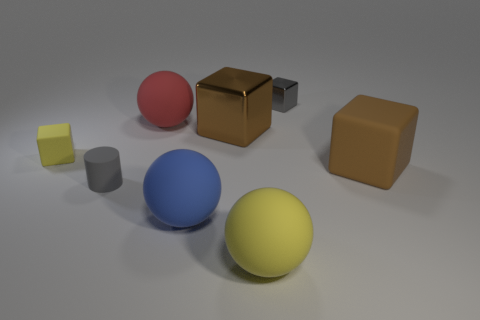Subtract 1 blocks. How many blocks are left? 3 Subtract all cyan blocks. Subtract all purple cylinders. How many blocks are left? 4 Add 1 metal blocks. How many objects exist? 9 Subtract all cylinders. How many objects are left? 7 Add 8 small cylinders. How many small cylinders are left? 9 Add 2 big brown metal cubes. How many big brown metal cubes exist? 3 Subtract 1 gray cylinders. How many objects are left? 7 Subtract all yellow objects. Subtract all tiny objects. How many objects are left? 3 